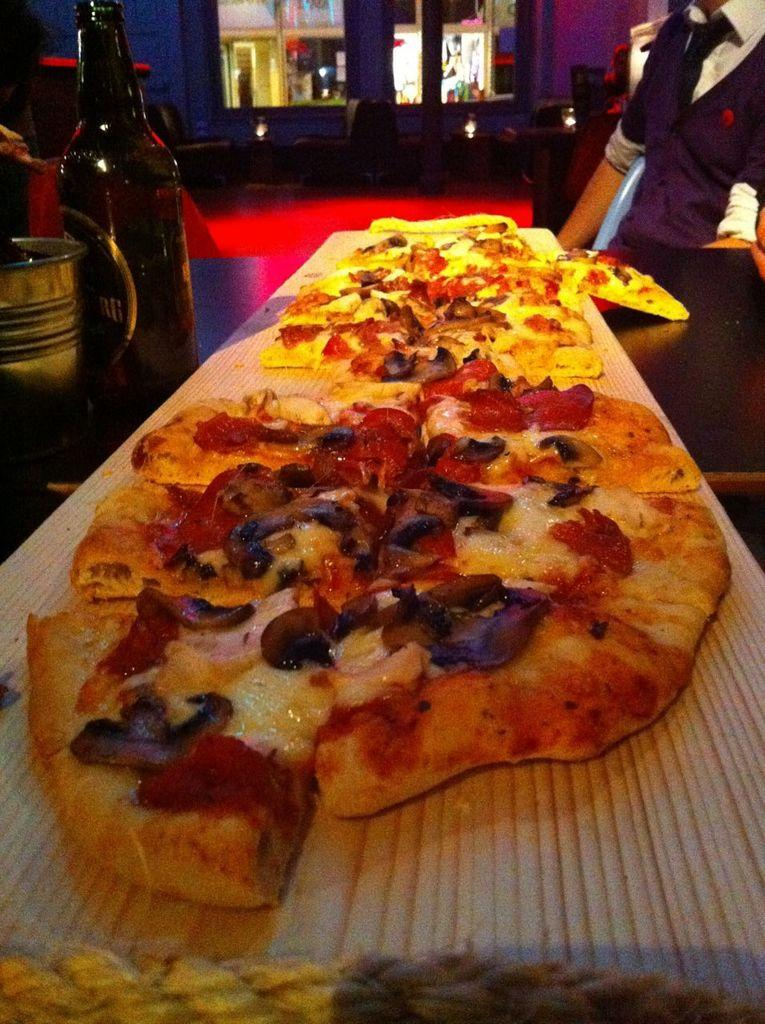What food item is present on the table in the image? There is a pizza on the table. What beverage is also present on the table? There is a wine bottle on the table. Can you describe the setting in the background of the image? There is a person sitting on a chair in the background. What can be seen through the window glass? The window glass is visible, but the image does not show what can be seen through it. What type of bell can be heard ringing in the image? There is no bell present or audible in the image. Can you describe the waves in the image? There are no waves present in the image. 